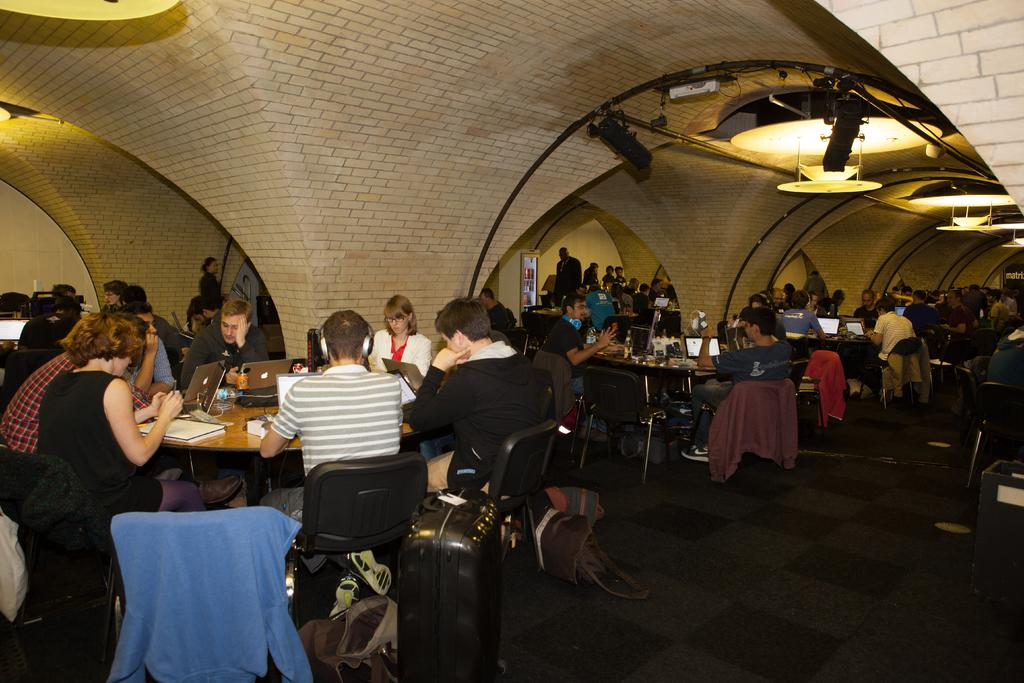What type of furniture is present in the image? There are tables and chairs in the image. What can be seen on the right side of the image? There are lights on the right side of the image. What are the people in the image doing? People are sitting on the chairs. What items can be seen on the tables? There are books, papers, and laptops on the tables. What additional items are present in the image? There are bags in the image. What type of crib is visible in the image? There is no crib present in the image. What kind of bread can be seen on the tables? There is no bread visible in the image; instead, there are books, papers, and laptops on the tables. 